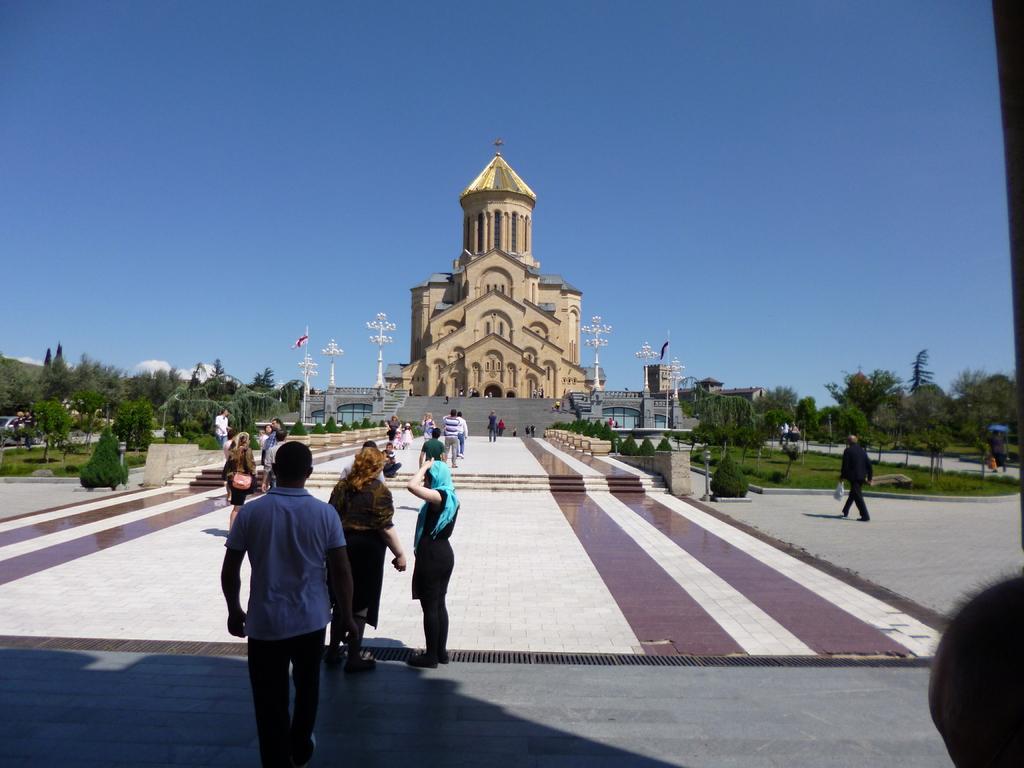Describe this image in one or two sentences. In the image there are few people walking and standing on the path towards castle in the front, there are trees on either side of it and above its sky. 